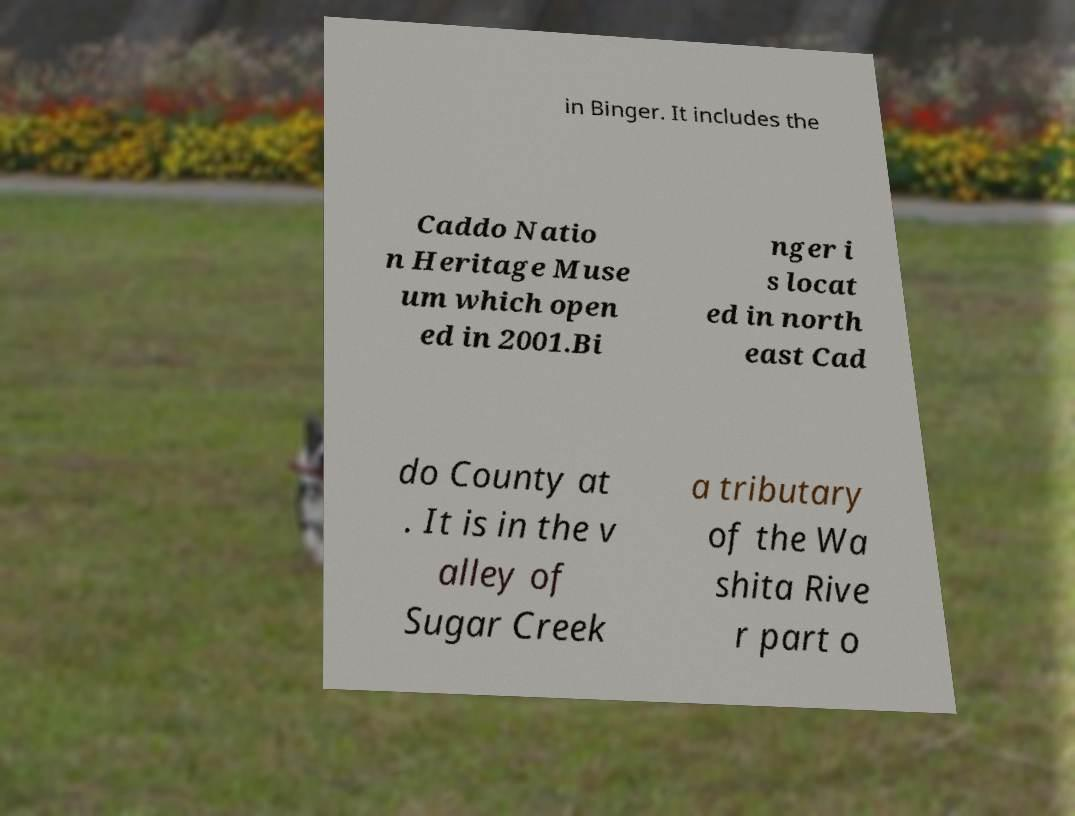Please identify and transcribe the text found in this image. in Binger. It includes the Caddo Natio n Heritage Muse um which open ed in 2001.Bi nger i s locat ed in north east Cad do County at . It is in the v alley of Sugar Creek a tributary of the Wa shita Rive r part o 